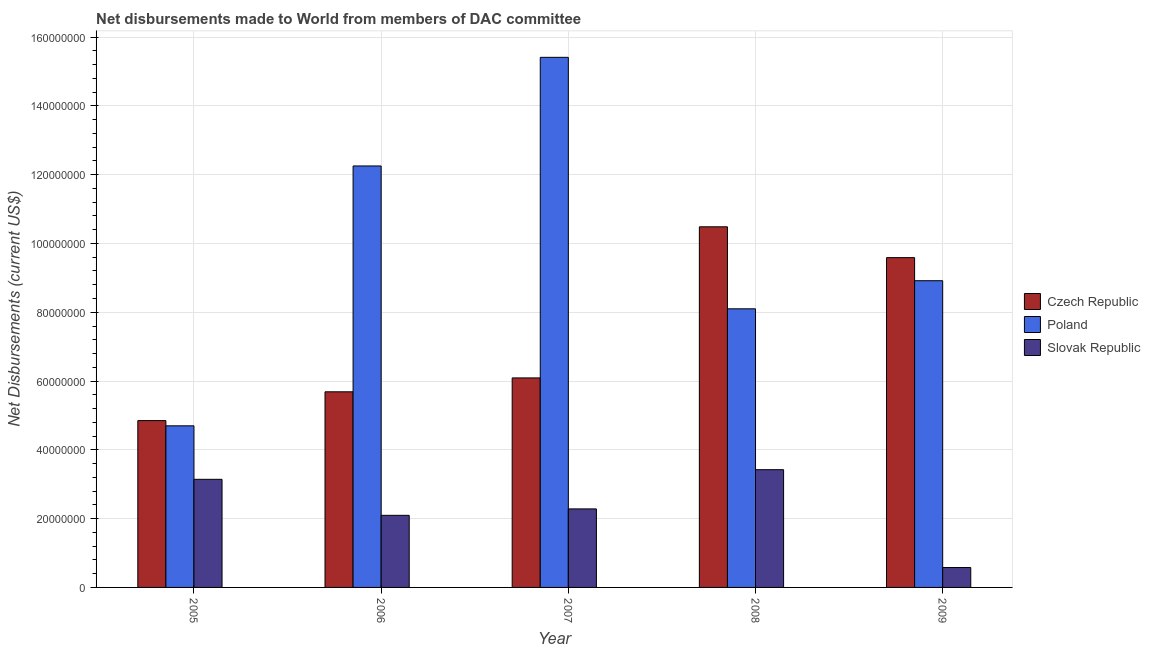How many different coloured bars are there?
Ensure brevity in your answer.  3. How many bars are there on the 2nd tick from the right?
Offer a terse response. 3. What is the label of the 1st group of bars from the left?
Give a very brief answer. 2005. What is the net disbursements made by poland in 2009?
Offer a very short reply. 8.92e+07. Across all years, what is the maximum net disbursements made by czech republic?
Your answer should be very brief. 1.05e+08. Across all years, what is the minimum net disbursements made by slovak republic?
Ensure brevity in your answer.  5.78e+06. In which year was the net disbursements made by slovak republic minimum?
Provide a succinct answer. 2009. What is the total net disbursements made by czech republic in the graph?
Your response must be concise. 3.67e+08. What is the difference between the net disbursements made by czech republic in 2005 and that in 2008?
Ensure brevity in your answer.  -5.63e+07. What is the difference between the net disbursements made by slovak republic in 2007 and the net disbursements made by czech republic in 2006?
Your answer should be compact. 1.87e+06. What is the average net disbursements made by czech republic per year?
Your answer should be compact. 7.34e+07. In how many years, is the net disbursements made by czech republic greater than 144000000 US$?
Offer a terse response. 0. What is the ratio of the net disbursements made by czech republic in 2007 to that in 2008?
Give a very brief answer. 0.58. Is the net disbursements made by poland in 2006 less than that in 2008?
Provide a succinct answer. No. Is the difference between the net disbursements made by poland in 2008 and 2009 greater than the difference between the net disbursements made by slovak republic in 2008 and 2009?
Your answer should be compact. No. What is the difference between the highest and the second highest net disbursements made by czech republic?
Your response must be concise. 8.96e+06. What is the difference between the highest and the lowest net disbursements made by czech republic?
Keep it short and to the point. 5.63e+07. Is the sum of the net disbursements made by slovak republic in 2006 and 2009 greater than the maximum net disbursements made by poland across all years?
Offer a very short reply. No. What does the 3rd bar from the left in 2005 represents?
Offer a very short reply. Slovak Republic. What does the 3rd bar from the right in 2005 represents?
Your answer should be compact. Czech Republic. Is it the case that in every year, the sum of the net disbursements made by czech republic and net disbursements made by poland is greater than the net disbursements made by slovak republic?
Your answer should be compact. Yes. How many bars are there?
Make the answer very short. 15. What is the difference between two consecutive major ticks on the Y-axis?
Keep it short and to the point. 2.00e+07. Does the graph contain grids?
Your answer should be compact. Yes. How many legend labels are there?
Ensure brevity in your answer.  3. What is the title of the graph?
Provide a short and direct response. Net disbursements made to World from members of DAC committee. Does "Primary education" appear as one of the legend labels in the graph?
Keep it short and to the point. No. What is the label or title of the Y-axis?
Your answer should be compact. Net Disbursements (current US$). What is the Net Disbursements (current US$) of Czech Republic in 2005?
Keep it short and to the point. 4.85e+07. What is the Net Disbursements (current US$) of Poland in 2005?
Ensure brevity in your answer.  4.70e+07. What is the Net Disbursements (current US$) of Slovak Republic in 2005?
Your response must be concise. 3.14e+07. What is the Net Disbursements (current US$) in Czech Republic in 2006?
Offer a very short reply. 5.69e+07. What is the Net Disbursements (current US$) of Poland in 2006?
Ensure brevity in your answer.  1.23e+08. What is the Net Disbursements (current US$) of Slovak Republic in 2006?
Offer a terse response. 2.10e+07. What is the Net Disbursements (current US$) of Czech Republic in 2007?
Your answer should be compact. 6.09e+07. What is the Net Disbursements (current US$) of Poland in 2007?
Provide a short and direct response. 1.54e+08. What is the Net Disbursements (current US$) in Slovak Republic in 2007?
Your answer should be compact. 2.28e+07. What is the Net Disbursements (current US$) of Czech Republic in 2008?
Your response must be concise. 1.05e+08. What is the Net Disbursements (current US$) of Poland in 2008?
Your answer should be very brief. 8.10e+07. What is the Net Disbursements (current US$) in Slovak Republic in 2008?
Your answer should be very brief. 3.42e+07. What is the Net Disbursements (current US$) of Czech Republic in 2009?
Your answer should be very brief. 9.59e+07. What is the Net Disbursements (current US$) of Poland in 2009?
Provide a short and direct response. 8.92e+07. What is the Net Disbursements (current US$) in Slovak Republic in 2009?
Your answer should be compact. 5.78e+06. Across all years, what is the maximum Net Disbursements (current US$) in Czech Republic?
Your answer should be very brief. 1.05e+08. Across all years, what is the maximum Net Disbursements (current US$) of Poland?
Keep it short and to the point. 1.54e+08. Across all years, what is the maximum Net Disbursements (current US$) of Slovak Republic?
Offer a terse response. 3.42e+07. Across all years, what is the minimum Net Disbursements (current US$) of Czech Republic?
Ensure brevity in your answer.  4.85e+07. Across all years, what is the minimum Net Disbursements (current US$) of Poland?
Keep it short and to the point. 4.70e+07. Across all years, what is the minimum Net Disbursements (current US$) in Slovak Republic?
Your response must be concise. 5.78e+06. What is the total Net Disbursements (current US$) of Czech Republic in the graph?
Your answer should be very brief. 3.67e+08. What is the total Net Disbursements (current US$) of Poland in the graph?
Ensure brevity in your answer.  4.94e+08. What is the total Net Disbursements (current US$) in Slovak Republic in the graph?
Your response must be concise. 1.15e+08. What is the difference between the Net Disbursements (current US$) of Czech Republic in 2005 and that in 2006?
Make the answer very short. -8.37e+06. What is the difference between the Net Disbursements (current US$) in Poland in 2005 and that in 2006?
Your answer should be very brief. -7.56e+07. What is the difference between the Net Disbursements (current US$) in Slovak Republic in 2005 and that in 2006?
Offer a very short reply. 1.05e+07. What is the difference between the Net Disbursements (current US$) in Czech Republic in 2005 and that in 2007?
Provide a short and direct response. -1.24e+07. What is the difference between the Net Disbursements (current US$) of Poland in 2005 and that in 2007?
Offer a terse response. -1.07e+08. What is the difference between the Net Disbursements (current US$) in Slovak Republic in 2005 and that in 2007?
Provide a succinct answer. 8.60e+06. What is the difference between the Net Disbursements (current US$) in Czech Republic in 2005 and that in 2008?
Give a very brief answer. -5.63e+07. What is the difference between the Net Disbursements (current US$) in Poland in 2005 and that in 2008?
Keep it short and to the point. -3.40e+07. What is the difference between the Net Disbursements (current US$) of Slovak Republic in 2005 and that in 2008?
Provide a short and direct response. -2.80e+06. What is the difference between the Net Disbursements (current US$) of Czech Republic in 2005 and that in 2009?
Provide a short and direct response. -4.74e+07. What is the difference between the Net Disbursements (current US$) in Poland in 2005 and that in 2009?
Your response must be concise. -4.22e+07. What is the difference between the Net Disbursements (current US$) of Slovak Republic in 2005 and that in 2009?
Your response must be concise. 2.56e+07. What is the difference between the Net Disbursements (current US$) of Czech Republic in 2006 and that in 2007?
Keep it short and to the point. -4.04e+06. What is the difference between the Net Disbursements (current US$) of Poland in 2006 and that in 2007?
Provide a succinct answer. -3.16e+07. What is the difference between the Net Disbursements (current US$) in Slovak Republic in 2006 and that in 2007?
Keep it short and to the point. -1.87e+06. What is the difference between the Net Disbursements (current US$) of Czech Republic in 2006 and that in 2008?
Give a very brief answer. -4.80e+07. What is the difference between the Net Disbursements (current US$) in Poland in 2006 and that in 2008?
Provide a succinct answer. 4.15e+07. What is the difference between the Net Disbursements (current US$) in Slovak Republic in 2006 and that in 2008?
Your answer should be very brief. -1.33e+07. What is the difference between the Net Disbursements (current US$) in Czech Republic in 2006 and that in 2009?
Give a very brief answer. -3.90e+07. What is the difference between the Net Disbursements (current US$) of Poland in 2006 and that in 2009?
Offer a very short reply. 3.34e+07. What is the difference between the Net Disbursements (current US$) of Slovak Republic in 2006 and that in 2009?
Provide a short and direct response. 1.52e+07. What is the difference between the Net Disbursements (current US$) of Czech Republic in 2007 and that in 2008?
Give a very brief answer. -4.39e+07. What is the difference between the Net Disbursements (current US$) in Poland in 2007 and that in 2008?
Keep it short and to the point. 7.31e+07. What is the difference between the Net Disbursements (current US$) of Slovak Republic in 2007 and that in 2008?
Ensure brevity in your answer.  -1.14e+07. What is the difference between the Net Disbursements (current US$) in Czech Republic in 2007 and that in 2009?
Provide a short and direct response. -3.50e+07. What is the difference between the Net Disbursements (current US$) in Poland in 2007 and that in 2009?
Keep it short and to the point. 6.49e+07. What is the difference between the Net Disbursements (current US$) in Slovak Republic in 2007 and that in 2009?
Give a very brief answer. 1.70e+07. What is the difference between the Net Disbursements (current US$) of Czech Republic in 2008 and that in 2009?
Offer a terse response. 8.96e+06. What is the difference between the Net Disbursements (current US$) of Poland in 2008 and that in 2009?
Your response must be concise. -8.17e+06. What is the difference between the Net Disbursements (current US$) of Slovak Republic in 2008 and that in 2009?
Your response must be concise. 2.84e+07. What is the difference between the Net Disbursements (current US$) of Czech Republic in 2005 and the Net Disbursements (current US$) of Poland in 2006?
Your response must be concise. -7.40e+07. What is the difference between the Net Disbursements (current US$) of Czech Republic in 2005 and the Net Disbursements (current US$) of Slovak Republic in 2006?
Your answer should be very brief. 2.75e+07. What is the difference between the Net Disbursements (current US$) of Poland in 2005 and the Net Disbursements (current US$) of Slovak Republic in 2006?
Keep it short and to the point. 2.60e+07. What is the difference between the Net Disbursements (current US$) of Czech Republic in 2005 and the Net Disbursements (current US$) of Poland in 2007?
Your response must be concise. -1.06e+08. What is the difference between the Net Disbursements (current US$) of Czech Republic in 2005 and the Net Disbursements (current US$) of Slovak Republic in 2007?
Offer a very short reply. 2.57e+07. What is the difference between the Net Disbursements (current US$) in Poland in 2005 and the Net Disbursements (current US$) in Slovak Republic in 2007?
Your answer should be compact. 2.42e+07. What is the difference between the Net Disbursements (current US$) of Czech Republic in 2005 and the Net Disbursements (current US$) of Poland in 2008?
Offer a very short reply. -3.25e+07. What is the difference between the Net Disbursements (current US$) in Czech Republic in 2005 and the Net Disbursements (current US$) in Slovak Republic in 2008?
Your answer should be compact. 1.43e+07. What is the difference between the Net Disbursements (current US$) of Poland in 2005 and the Net Disbursements (current US$) of Slovak Republic in 2008?
Your response must be concise. 1.28e+07. What is the difference between the Net Disbursements (current US$) of Czech Republic in 2005 and the Net Disbursements (current US$) of Poland in 2009?
Ensure brevity in your answer.  -4.07e+07. What is the difference between the Net Disbursements (current US$) of Czech Republic in 2005 and the Net Disbursements (current US$) of Slovak Republic in 2009?
Give a very brief answer. 4.27e+07. What is the difference between the Net Disbursements (current US$) of Poland in 2005 and the Net Disbursements (current US$) of Slovak Republic in 2009?
Your answer should be very brief. 4.12e+07. What is the difference between the Net Disbursements (current US$) in Czech Republic in 2006 and the Net Disbursements (current US$) in Poland in 2007?
Give a very brief answer. -9.72e+07. What is the difference between the Net Disbursements (current US$) in Czech Republic in 2006 and the Net Disbursements (current US$) in Slovak Republic in 2007?
Give a very brief answer. 3.40e+07. What is the difference between the Net Disbursements (current US$) of Poland in 2006 and the Net Disbursements (current US$) of Slovak Republic in 2007?
Offer a very short reply. 9.97e+07. What is the difference between the Net Disbursements (current US$) of Czech Republic in 2006 and the Net Disbursements (current US$) of Poland in 2008?
Make the answer very short. -2.41e+07. What is the difference between the Net Disbursements (current US$) in Czech Republic in 2006 and the Net Disbursements (current US$) in Slovak Republic in 2008?
Offer a terse response. 2.26e+07. What is the difference between the Net Disbursements (current US$) in Poland in 2006 and the Net Disbursements (current US$) in Slovak Republic in 2008?
Keep it short and to the point. 8.83e+07. What is the difference between the Net Disbursements (current US$) of Czech Republic in 2006 and the Net Disbursements (current US$) of Poland in 2009?
Keep it short and to the point. -3.23e+07. What is the difference between the Net Disbursements (current US$) of Czech Republic in 2006 and the Net Disbursements (current US$) of Slovak Republic in 2009?
Your answer should be compact. 5.11e+07. What is the difference between the Net Disbursements (current US$) of Poland in 2006 and the Net Disbursements (current US$) of Slovak Republic in 2009?
Ensure brevity in your answer.  1.17e+08. What is the difference between the Net Disbursements (current US$) of Czech Republic in 2007 and the Net Disbursements (current US$) of Poland in 2008?
Ensure brevity in your answer.  -2.01e+07. What is the difference between the Net Disbursements (current US$) in Czech Republic in 2007 and the Net Disbursements (current US$) in Slovak Republic in 2008?
Ensure brevity in your answer.  2.67e+07. What is the difference between the Net Disbursements (current US$) in Poland in 2007 and the Net Disbursements (current US$) in Slovak Republic in 2008?
Your response must be concise. 1.20e+08. What is the difference between the Net Disbursements (current US$) of Czech Republic in 2007 and the Net Disbursements (current US$) of Poland in 2009?
Make the answer very short. -2.83e+07. What is the difference between the Net Disbursements (current US$) of Czech Republic in 2007 and the Net Disbursements (current US$) of Slovak Republic in 2009?
Offer a very short reply. 5.51e+07. What is the difference between the Net Disbursements (current US$) of Poland in 2007 and the Net Disbursements (current US$) of Slovak Republic in 2009?
Offer a terse response. 1.48e+08. What is the difference between the Net Disbursements (current US$) of Czech Republic in 2008 and the Net Disbursements (current US$) of Poland in 2009?
Provide a succinct answer. 1.57e+07. What is the difference between the Net Disbursements (current US$) in Czech Republic in 2008 and the Net Disbursements (current US$) in Slovak Republic in 2009?
Make the answer very short. 9.91e+07. What is the difference between the Net Disbursements (current US$) of Poland in 2008 and the Net Disbursements (current US$) of Slovak Republic in 2009?
Keep it short and to the point. 7.52e+07. What is the average Net Disbursements (current US$) in Czech Republic per year?
Ensure brevity in your answer.  7.34e+07. What is the average Net Disbursements (current US$) of Poland per year?
Keep it short and to the point. 9.88e+07. What is the average Net Disbursements (current US$) of Slovak Republic per year?
Ensure brevity in your answer.  2.30e+07. In the year 2005, what is the difference between the Net Disbursements (current US$) of Czech Republic and Net Disbursements (current US$) of Poland?
Offer a very short reply. 1.52e+06. In the year 2005, what is the difference between the Net Disbursements (current US$) of Czech Republic and Net Disbursements (current US$) of Slovak Republic?
Your answer should be very brief. 1.71e+07. In the year 2005, what is the difference between the Net Disbursements (current US$) of Poland and Net Disbursements (current US$) of Slovak Republic?
Your response must be concise. 1.56e+07. In the year 2006, what is the difference between the Net Disbursements (current US$) in Czech Republic and Net Disbursements (current US$) in Poland?
Give a very brief answer. -6.57e+07. In the year 2006, what is the difference between the Net Disbursements (current US$) in Czech Republic and Net Disbursements (current US$) in Slovak Republic?
Provide a succinct answer. 3.59e+07. In the year 2006, what is the difference between the Net Disbursements (current US$) of Poland and Net Disbursements (current US$) of Slovak Republic?
Give a very brief answer. 1.02e+08. In the year 2007, what is the difference between the Net Disbursements (current US$) in Czech Republic and Net Disbursements (current US$) in Poland?
Provide a succinct answer. -9.32e+07. In the year 2007, what is the difference between the Net Disbursements (current US$) of Czech Republic and Net Disbursements (current US$) of Slovak Republic?
Make the answer very short. 3.81e+07. In the year 2007, what is the difference between the Net Disbursements (current US$) in Poland and Net Disbursements (current US$) in Slovak Republic?
Provide a succinct answer. 1.31e+08. In the year 2008, what is the difference between the Net Disbursements (current US$) in Czech Republic and Net Disbursements (current US$) in Poland?
Your answer should be compact. 2.38e+07. In the year 2008, what is the difference between the Net Disbursements (current US$) of Czech Republic and Net Disbursements (current US$) of Slovak Republic?
Your answer should be compact. 7.06e+07. In the year 2008, what is the difference between the Net Disbursements (current US$) in Poland and Net Disbursements (current US$) in Slovak Republic?
Keep it short and to the point. 4.68e+07. In the year 2009, what is the difference between the Net Disbursements (current US$) in Czech Republic and Net Disbursements (current US$) in Poland?
Your response must be concise. 6.71e+06. In the year 2009, what is the difference between the Net Disbursements (current US$) of Czech Republic and Net Disbursements (current US$) of Slovak Republic?
Your response must be concise. 9.01e+07. In the year 2009, what is the difference between the Net Disbursements (current US$) of Poland and Net Disbursements (current US$) of Slovak Republic?
Your answer should be compact. 8.34e+07. What is the ratio of the Net Disbursements (current US$) of Czech Republic in 2005 to that in 2006?
Ensure brevity in your answer.  0.85. What is the ratio of the Net Disbursements (current US$) in Poland in 2005 to that in 2006?
Keep it short and to the point. 0.38. What is the ratio of the Net Disbursements (current US$) in Slovak Republic in 2005 to that in 2006?
Your answer should be very brief. 1.5. What is the ratio of the Net Disbursements (current US$) in Czech Republic in 2005 to that in 2007?
Offer a very short reply. 0.8. What is the ratio of the Net Disbursements (current US$) of Poland in 2005 to that in 2007?
Offer a very short reply. 0.3. What is the ratio of the Net Disbursements (current US$) in Slovak Republic in 2005 to that in 2007?
Your answer should be compact. 1.38. What is the ratio of the Net Disbursements (current US$) of Czech Republic in 2005 to that in 2008?
Offer a very short reply. 0.46. What is the ratio of the Net Disbursements (current US$) of Poland in 2005 to that in 2008?
Make the answer very short. 0.58. What is the ratio of the Net Disbursements (current US$) of Slovak Republic in 2005 to that in 2008?
Provide a short and direct response. 0.92. What is the ratio of the Net Disbursements (current US$) of Czech Republic in 2005 to that in 2009?
Give a very brief answer. 0.51. What is the ratio of the Net Disbursements (current US$) in Poland in 2005 to that in 2009?
Provide a succinct answer. 0.53. What is the ratio of the Net Disbursements (current US$) of Slovak Republic in 2005 to that in 2009?
Offer a terse response. 5.44. What is the ratio of the Net Disbursements (current US$) in Czech Republic in 2006 to that in 2007?
Offer a terse response. 0.93. What is the ratio of the Net Disbursements (current US$) of Poland in 2006 to that in 2007?
Ensure brevity in your answer.  0.8. What is the ratio of the Net Disbursements (current US$) of Slovak Republic in 2006 to that in 2007?
Keep it short and to the point. 0.92. What is the ratio of the Net Disbursements (current US$) in Czech Republic in 2006 to that in 2008?
Ensure brevity in your answer.  0.54. What is the ratio of the Net Disbursements (current US$) of Poland in 2006 to that in 2008?
Keep it short and to the point. 1.51. What is the ratio of the Net Disbursements (current US$) of Slovak Republic in 2006 to that in 2008?
Your response must be concise. 0.61. What is the ratio of the Net Disbursements (current US$) of Czech Republic in 2006 to that in 2009?
Your answer should be very brief. 0.59. What is the ratio of the Net Disbursements (current US$) in Poland in 2006 to that in 2009?
Offer a terse response. 1.37. What is the ratio of the Net Disbursements (current US$) of Slovak Republic in 2006 to that in 2009?
Keep it short and to the point. 3.63. What is the ratio of the Net Disbursements (current US$) in Czech Republic in 2007 to that in 2008?
Keep it short and to the point. 0.58. What is the ratio of the Net Disbursements (current US$) in Poland in 2007 to that in 2008?
Keep it short and to the point. 1.9. What is the ratio of the Net Disbursements (current US$) in Slovak Republic in 2007 to that in 2008?
Make the answer very short. 0.67. What is the ratio of the Net Disbursements (current US$) of Czech Republic in 2007 to that in 2009?
Offer a very short reply. 0.64. What is the ratio of the Net Disbursements (current US$) of Poland in 2007 to that in 2009?
Your response must be concise. 1.73. What is the ratio of the Net Disbursements (current US$) of Slovak Republic in 2007 to that in 2009?
Your answer should be compact. 3.95. What is the ratio of the Net Disbursements (current US$) of Czech Republic in 2008 to that in 2009?
Your response must be concise. 1.09. What is the ratio of the Net Disbursements (current US$) in Poland in 2008 to that in 2009?
Provide a succinct answer. 0.91. What is the ratio of the Net Disbursements (current US$) in Slovak Republic in 2008 to that in 2009?
Give a very brief answer. 5.92. What is the difference between the highest and the second highest Net Disbursements (current US$) in Czech Republic?
Make the answer very short. 8.96e+06. What is the difference between the highest and the second highest Net Disbursements (current US$) in Poland?
Your answer should be compact. 3.16e+07. What is the difference between the highest and the second highest Net Disbursements (current US$) of Slovak Republic?
Provide a succinct answer. 2.80e+06. What is the difference between the highest and the lowest Net Disbursements (current US$) in Czech Republic?
Your answer should be compact. 5.63e+07. What is the difference between the highest and the lowest Net Disbursements (current US$) in Poland?
Offer a terse response. 1.07e+08. What is the difference between the highest and the lowest Net Disbursements (current US$) of Slovak Republic?
Give a very brief answer. 2.84e+07. 